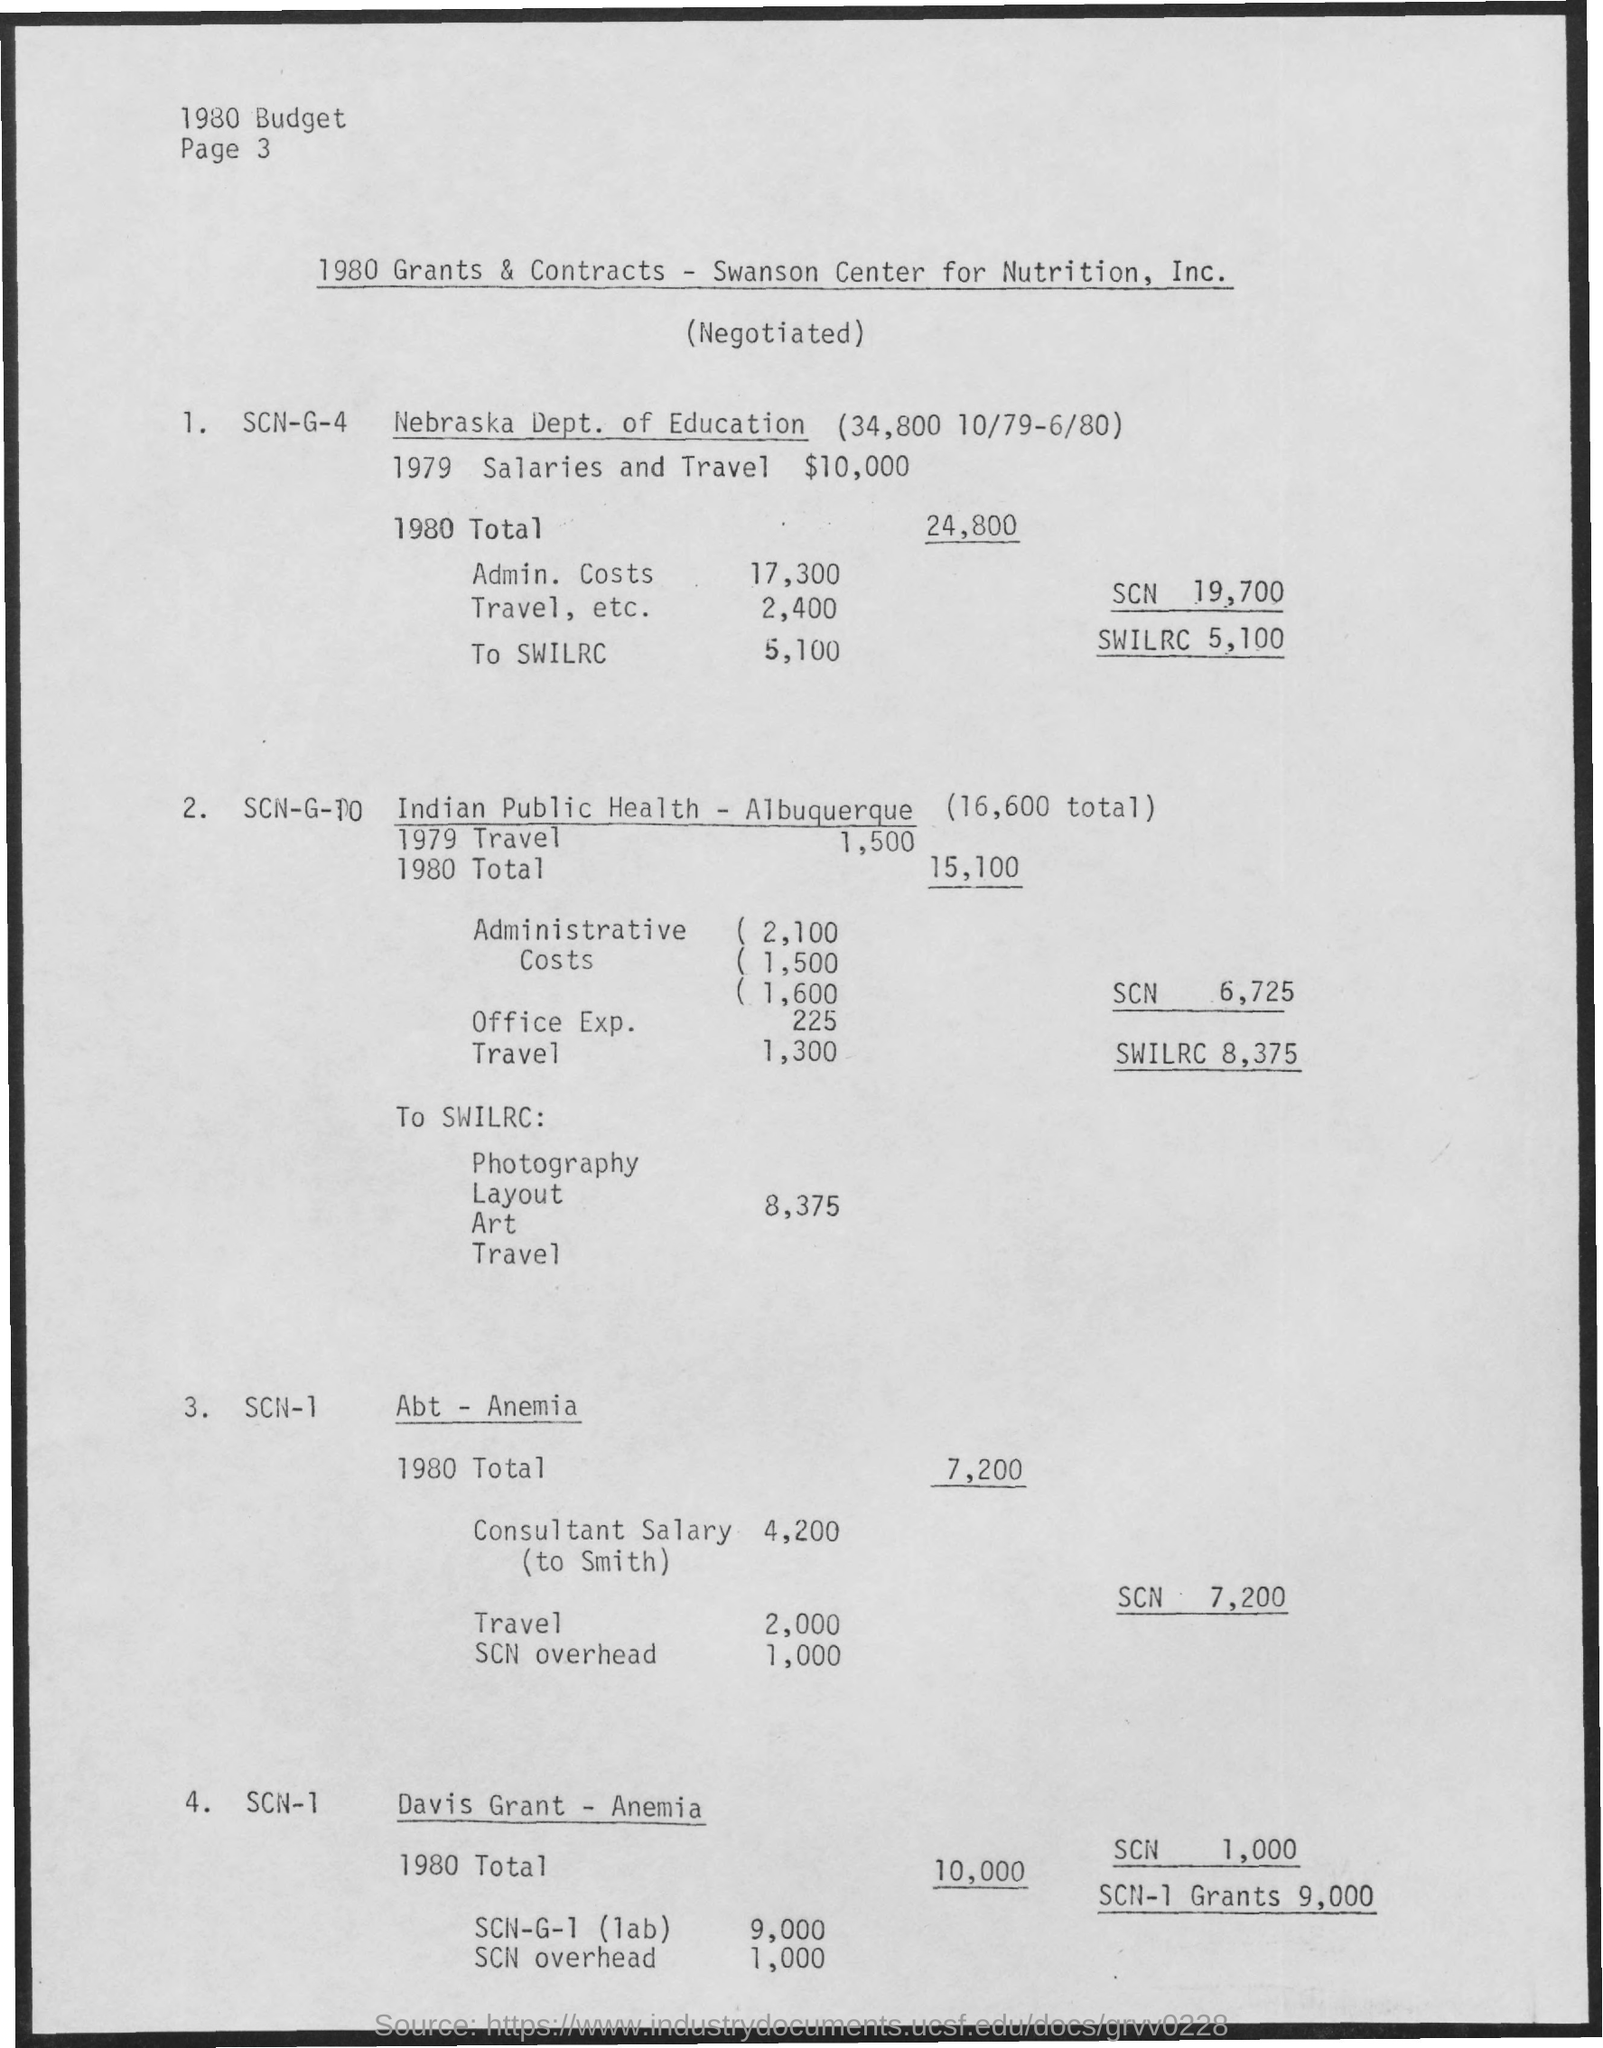Give some essential details in this illustration. In 1980, the total for the Nebraska Department of Education was 24,800. The 1980 Title I program in Nebraska, administered by the Nebraska Department of Education, served approximately 5,100 students during the 1980-1981 school year. In 1979, the Indian Public Health in Albuquerque traveled for a purpose. The purpose was 1,500. The 1980 Travel, etc. for Nebraska Dept. of Education was 2,400. In 1979, the salaries and travel expenses for the Nebraska Department of Education totaled $10,000. 